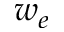Convert formula to latex. <formula><loc_0><loc_0><loc_500><loc_500>w _ { e }</formula> 